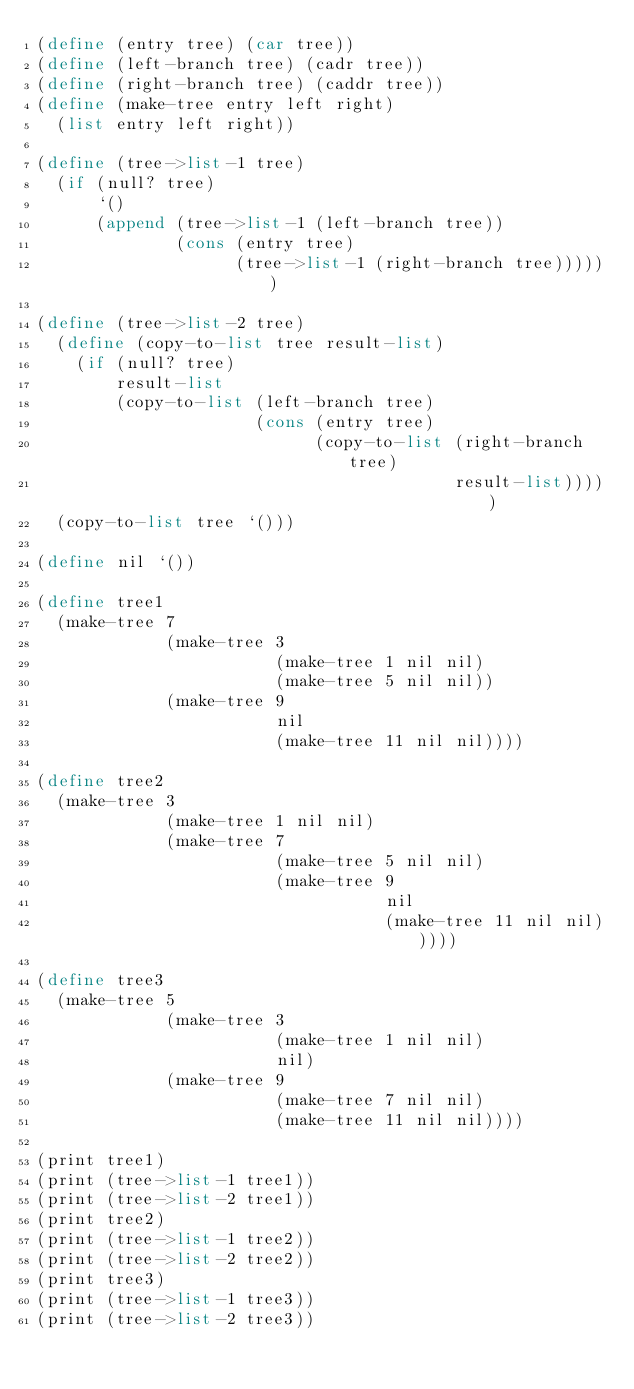<code> <loc_0><loc_0><loc_500><loc_500><_Scheme_>(define (entry tree) (car tree))
(define (left-branch tree) (cadr tree))
(define (right-branch tree) (caddr tree))
(define (make-tree entry left right)
  (list entry left right))

(define (tree->list-1 tree)
  (if (null? tree)
      `()
      (append (tree->list-1 (left-branch tree))
              (cons (entry tree)
                    (tree->list-1 (right-branch tree))))))

(define (tree->list-2 tree)
  (define (copy-to-list tree result-list)
    (if (null? tree)
        result-list
        (copy-to-list (left-branch tree)
                      (cons (entry tree)
                            (copy-to-list (right-branch tree)
                                          result-list)))))
  (copy-to-list tree `()))

(define nil `())

(define tree1
  (make-tree 7
             (make-tree 3
                        (make-tree 1 nil nil)
                        (make-tree 5 nil nil))
             (make-tree 9
                        nil
                        (make-tree 11 nil nil))))

(define tree2
  (make-tree 3
             (make-tree 1 nil nil)
             (make-tree 7
                        (make-tree 5 nil nil)
                        (make-tree 9
                                   nil
                                   (make-tree 11 nil nil)))))

(define tree3
  (make-tree 5
             (make-tree 3
                        (make-tree 1 nil nil)
                        nil)
             (make-tree 9
                        (make-tree 7 nil nil)
                        (make-tree 11 nil nil))))

(print tree1)
(print (tree->list-1 tree1))
(print (tree->list-2 tree1))
(print tree2)
(print (tree->list-1 tree2))
(print (tree->list-2 tree2))
(print tree3)
(print (tree->list-1 tree3))
(print (tree->list-2 tree3))
</code> 